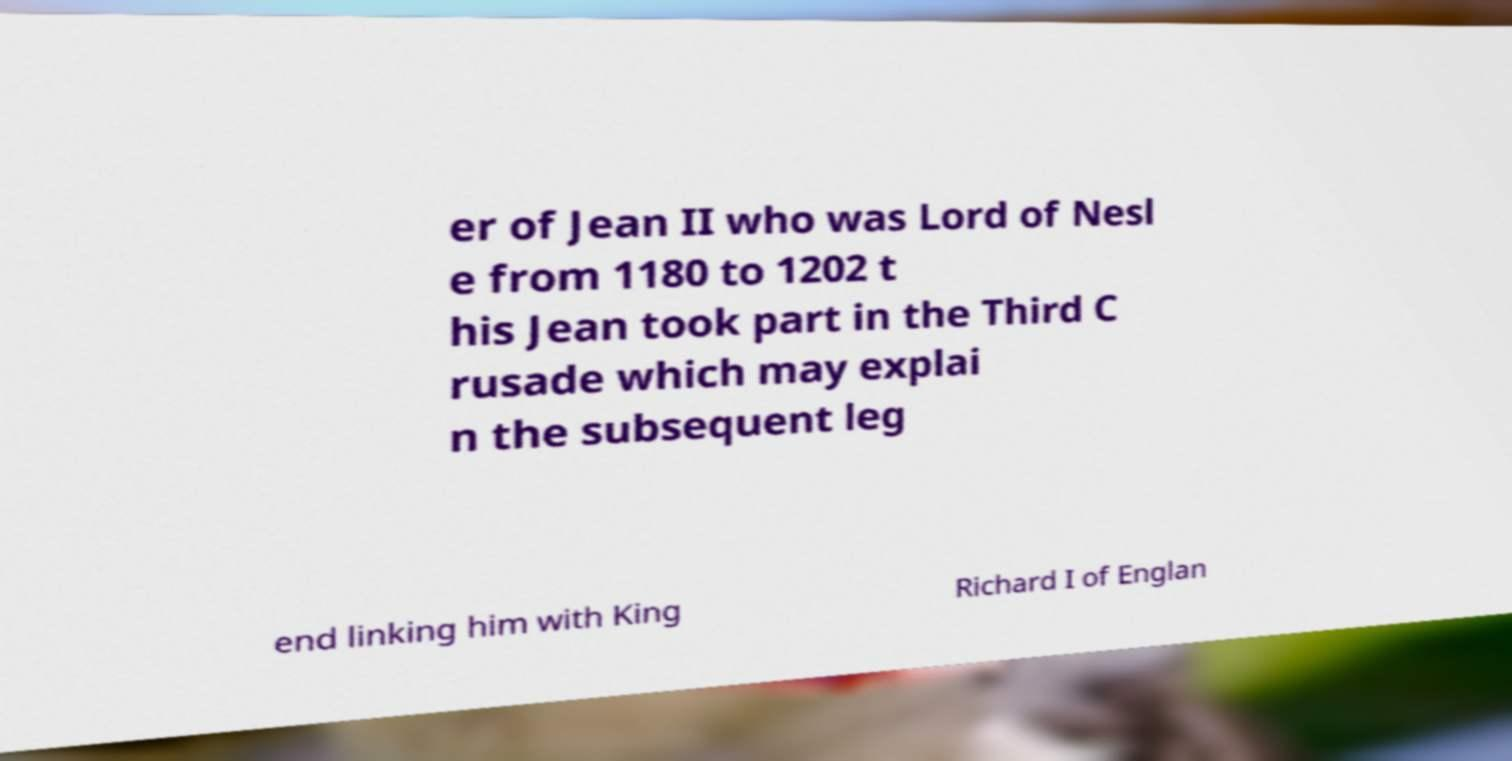There's text embedded in this image that I need extracted. Can you transcribe it verbatim? er of Jean II who was Lord of Nesl e from 1180 to 1202 t his Jean took part in the Third C rusade which may explai n the subsequent leg end linking him with King Richard I of Englan 